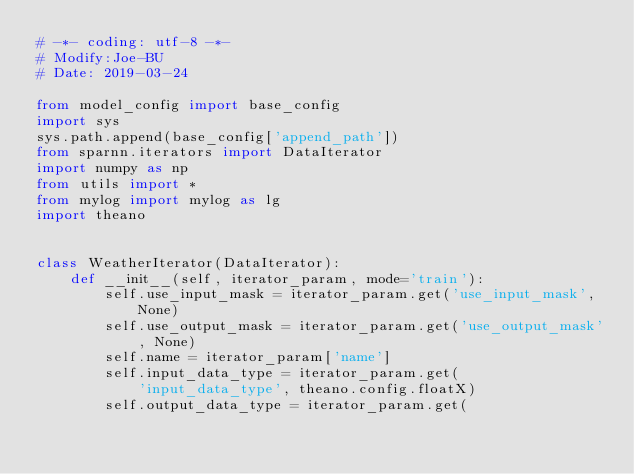<code> <loc_0><loc_0><loc_500><loc_500><_Python_># -*- coding: utf-8 -*-
# Modify:Joe-BU
# Date: 2019-03-24

from model_config import base_config
import sys
sys.path.append(base_config['append_path'])
from sparnn.iterators import DataIterator
import numpy as np
from utils import *
from mylog import mylog as lg
import theano


class WeatherIterator(DataIterator):
    def __init__(self, iterator_param, mode='train'):
        self.use_input_mask = iterator_param.get('use_input_mask', None)
        self.use_output_mask = iterator_param.get('use_output_mask', None)
        self.name = iterator_param['name']
        self.input_data_type = iterator_param.get(
            'input_data_type', theano.config.floatX)
        self.output_data_type = iterator_param.get(</code> 